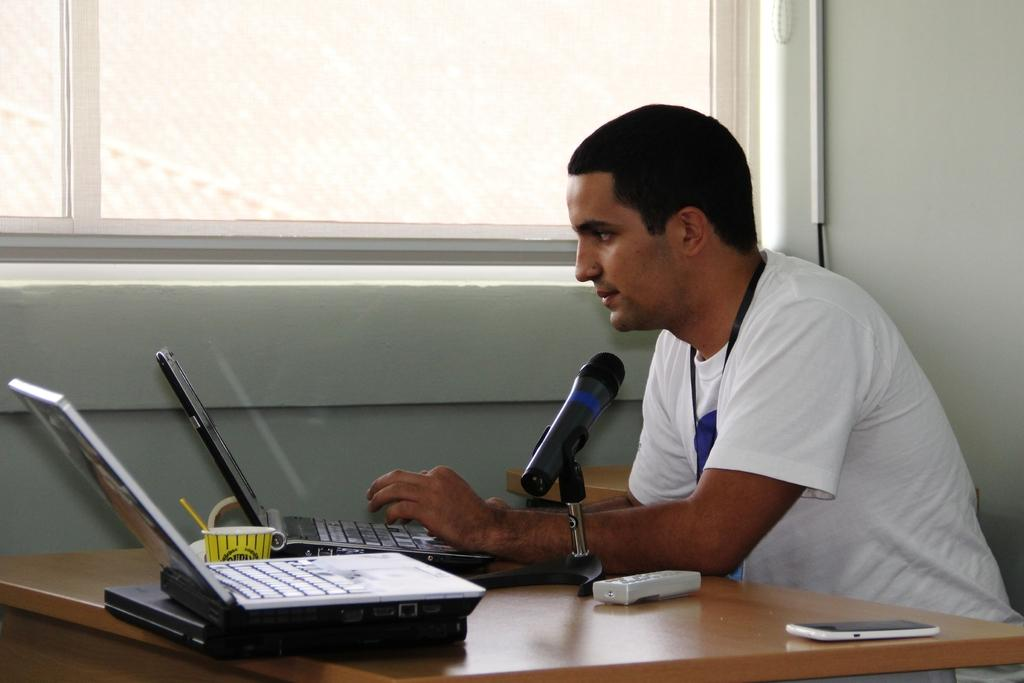What is the main subject of the image? There is a person in the image. What else can be seen in the image besides the person? There are objects placed on a table in the image, and a cable is visible. Is there any source of natural light in the image? Yes, there is a window in the image. Can you see a turkey flying outside the window in the image? No, there is no turkey or any indication of a flight visible in the image. 